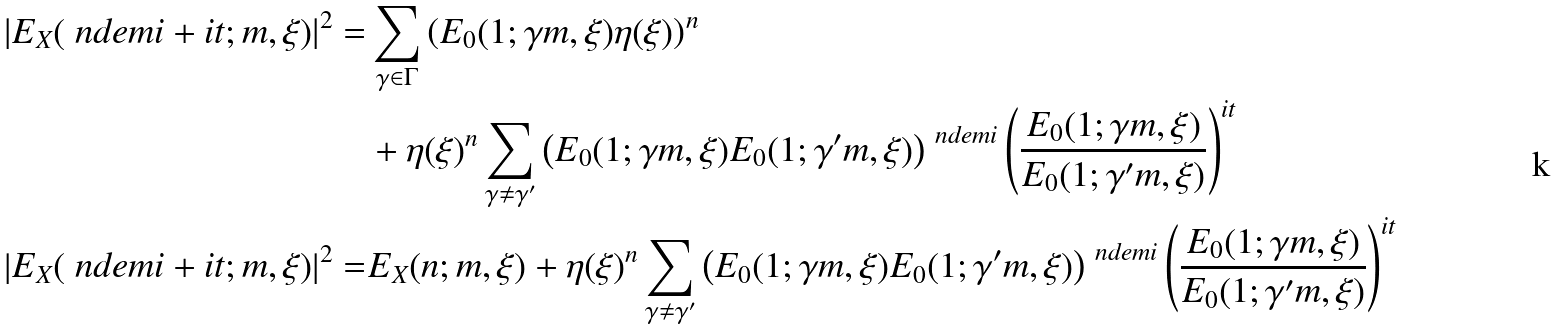<formula> <loc_0><loc_0><loc_500><loc_500>\left | E _ { X } ( \ n d e m i + i t ; m , \xi ) \right | ^ { 2 } = & \sum _ { \gamma \in \Gamma } \left ( E _ { 0 } ( 1 ; \gamma m , \xi ) \eta ( \xi ) \right ) ^ { n } \\ & + \eta ( \xi ) ^ { n } \sum _ { \gamma \not = \gamma ^ { \prime } } \left ( E _ { 0 } ( 1 ; \gamma m , \xi ) E _ { 0 } ( 1 ; \gamma ^ { \prime } m , \xi ) \right ) ^ { \ n d e m i } \left ( \frac { E _ { 0 } ( 1 ; \gamma m , \xi ) } { E _ { 0 } ( 1 ; \gamma ^ { \prime } m , \xi ) } \right ) ^ { i t } \\ \left | E _ { X } ( \ n d e m i + i t ; m , \xi ) \right | ^ { 2 } = & E _ { X } ( n ; m , \xi ) + \eta ( \xi ) ^ { n } \sum _ { \gamma \not = \gamma ^ { \prime } } \left ( E _ { 0 } ( 1 ; \gamma m , \xi ) E _ { 0 } ( 1 ; \gamma ^ { \prime } m , \xi ) \right ) ^ { \ n d e m i } \left ( \frac { E _ { 0 } ( 1 ; \gamma m , \xi ) } { E _ { 0 } ( 1 ; \gamma ^ { \prime } m , \xi ) } \right ) ^ { i t }</formula> 